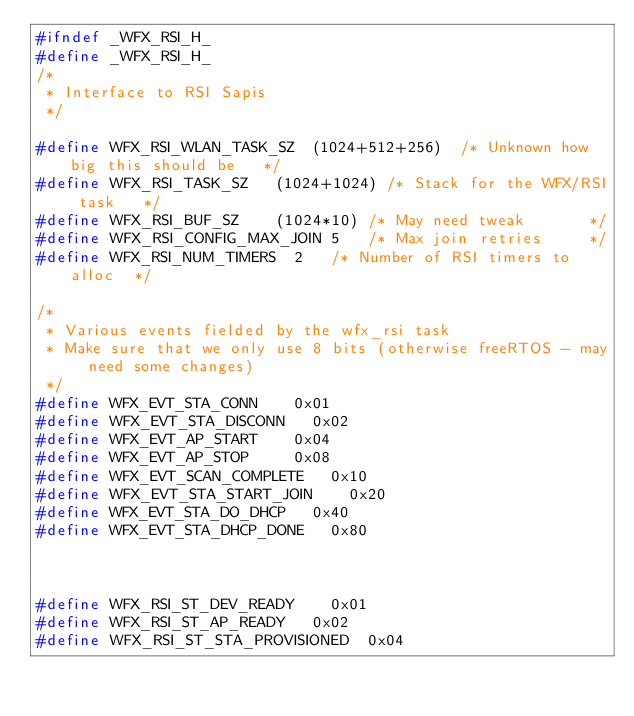<code> <loc_0><loc_0><loc_500><loc_500><_C_>#ifndef _WFX_RSI_H_
#define _WFX_RSI_H_
/*
 * Interface to RSI Sapis
 */

#define WFX_RSI_WLAN_TASK_SZ	(1024+512+256)	/* Unknown how big this should be 	*/
#define WFX_RSI_TASK_SZ		(1024+1024)	/* Stack for the WFX/RSI task		*/
#define WFX_RSI_BUF_SZ		(1024*10)	/* May need tweak 			*/
#define WFX_RSI_CONFIG_MAX_JOIN	5		/* Max join retries			*/
#define WFX_RSI_NUM_TIMERS	2		/* Number of RSI timers to alloc	*/

/*
 * Various events fielded by the wfx_rsi task
 * Make sure that we only use 8 bits (otherwise freeRTOS - may need some changes)
 */
#define WFX_EVT_STA_CONN		0x01
#define WFX_EVT_STA_DISCONN		0x02
#define WFX_EVT_AP_START		0x04
#define WFX_EVT_AP_STOP			0x08
#define WFX_EVT_SCAN_COMPLETE		0x10
#define WFX_EVT_STA_START_JOIN		0x20
#define WFX_EVT_STA_DO_DHCP		0x40
#define WFX_EVT_STA_DHCP_DONE		0x80



#define WFX_RSI_ST_DEV_READY 		0x01
#define WFX_RSI_ST_AP_READY		0x02
#define WFX_RSI_ST_STA_PROVISIONED	0x04</code> 